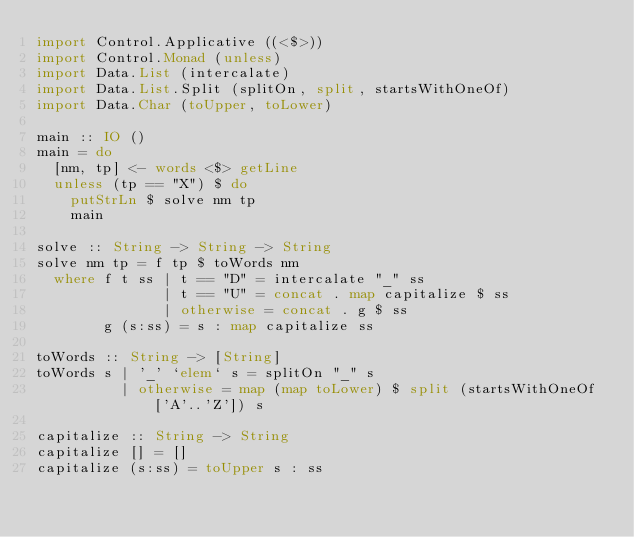Convert code to text. <code><loc_0><loc_0><loc_500><loc_500><_Haskell_>import Control.Applicative ((<$>))
import Control.Monad (unless)
import Data.List (intercalate)
import Data.List.Split (splitOn, split, startsWithOneOf)
import Data.Char (toUpper, toLower)

main :: IO ()
main = do
  [nm, tp] <- words <$> getLine
  unless (tp == "X") $ do
    putStrLn $ solve nm tp
    main

solve :: String -> String -> String
solve nm tp = f tp $ toWords nm
  where f t ss | t == "D" = intercalate "_" ss
               | t == "U" = concat . map capitalize $ ss
               | otherwise = concat . g $ ss
        g (s:ss) = s : map capitalize ss
          
toWords :: String -> [String]
toWords s | '_' `elem` s = splitOn "_" s
          | otherwise = map (map toLower) $ split (startsWithOneOf ['A'..'Z']) s

capitalize :: String -> String
capitalize [] = []
capitalize (s:ss) = toUpper s : ss

</code> 